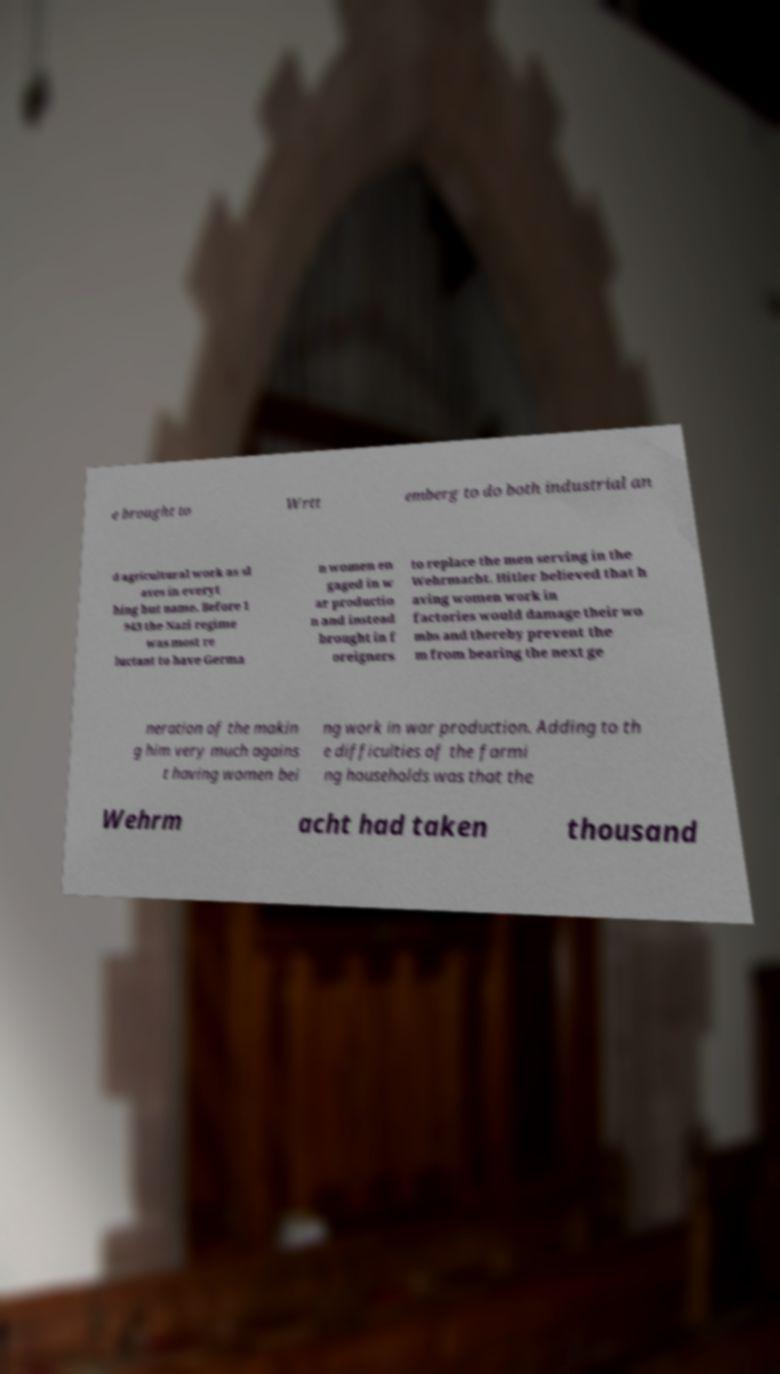What messages or text are displayed in this image? I need them in a readable, typed format. e brought to Wrtt emberg to do both industrial an d agricultural work as sl aves in everyt hing but name. Before 1 943 the Nazi regime was most re luctant to have Germa n women en gaged in w ar productio n and instead brought in f oreigners to replace the men serving in the Wehrmacht. Hitler believed that h aving women work in factories would damage their wo mbs and thereby prevent the m from bearing the next ge neration of the makin g him very much agains t having women bei ng work in war production. Adding to th e difficulties of the farmi ng households was that the Wehrm acht had taken thousand 